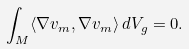Convert formula to latex. <formula><loc_0><loc_0><loc_500><loc_500>\int _ { M } \langle \nabla v _ { m } , \nabla v _ { m } \rangle \, d V _ { g } = 0 .</formula> 